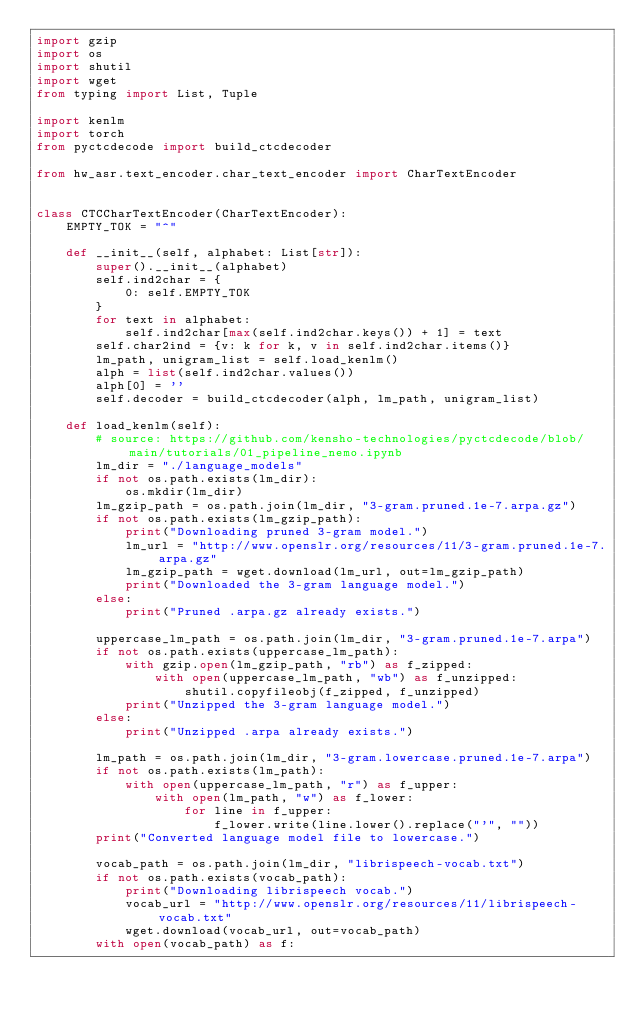Convert code to text. <code><loc_0><loc_0><loc_500><loc_500><_Python_>import gzip
import os
import shutil
import wget
from typing import List, Tuple

import kenlm
import torch
from pyctcdecode import build_ctcdecoder

from hw_asr.text_encoder.char_text_encoder import CharTextEncoder


class CTCCharTextEncoder(CharTextEncoder):
    EMPTY_TOK = "^"

    def __init__(self, alphabet: List[str]):
        super().__init__(alphabet)
        self.ind2char = {
            0: self.EMPTY_TOK
        }
        for text in alphabet:
            self.ind2char[max(self.ind2char.keys()) + 1] = text
        self.char2ind = {v: k for k, v in self.ind2char.items()}
        lm_path, unigram_list = self.load_kenlm()
        alph = list(self.ind2char.values())
        alph[0] = ''
        self.decoder = build_ctcdecoder(alph, lm_path, unigram_list)

    def load_kenlm(self):
        # source: https://github.com/kensho-technologies/pyctcdecode/blob/main/tutorials/01_pipeline_nemo.ipynb
        lm_dir = "./language_models"
        if not os.path.exists(lm_dir):
            os.mkdir(lm_dir)
        lm_gzip_path = os.path.join(lm_dir, "3-gram.pruned.1e-7.arpa.gz")
        if not os.path.exists(lm_gzip_path):
            print("Downloading pruned 3-gram model.")
            lm_url = "http://www.openslr.org/resources/11/3-gram.pruned.1e-7.arpa.gz"
            lm_gzip_path = wget.download(lm_url, out=lm_gzip_path)
            print("Downloaded the 3-gram language model.")
        else:
            print("Pruned .arpa.gz already exists.")

        uppercase_lm_path = os.path.join(lm_dir, "3-gram.pruned.1e-7.arpa")
        if not os.path.exists(uppercase_lm_path):
            with gzip.open(lm_gzip_path, "rb") as f_zipped:
                with open(uppercase_lm_path, "wb") as f_unzipped:
                    shutil.copyfileobj(f_zipped, f_unzipped)
            print("Unzipped the 3-gram language model.")
        else:
            print("Unzipped .arpa already exists.")

        lm_path = os.path.join(lm_dir, "3-gram.lowercase.pruned.1e-7.arpa")
        if not os.path.exists(lm_path):
            with open(uppercase_lm_path, "r") as f_upper:
                with open(lm_path, "w") as f_lower:
                    for line in f_upper:
                        f_lower.write(line.lower().replace("'", ""))
        print("Converted language model file to lowercase.")

        vocab_path = os.path.join(lm_dir, "librispeech-vocab.txt")
        if not os.path.exists(vocab_path):
            print("Downloading librispeech vocab.")
            vocab_url = "http://www.openslr.org/resources/11/librispeech-vocab.txt"
            wget.download(vocab_url, out=vocab_path)
        with open(vocab_path) as f:</code> 